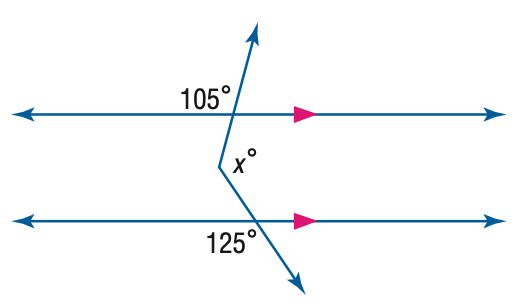Question: Find x. (Hint: Draw an auxiliary line).
Choices:
A. 105
B. 120
C. 125
D. 130
Answer with the letter. Answer: D 